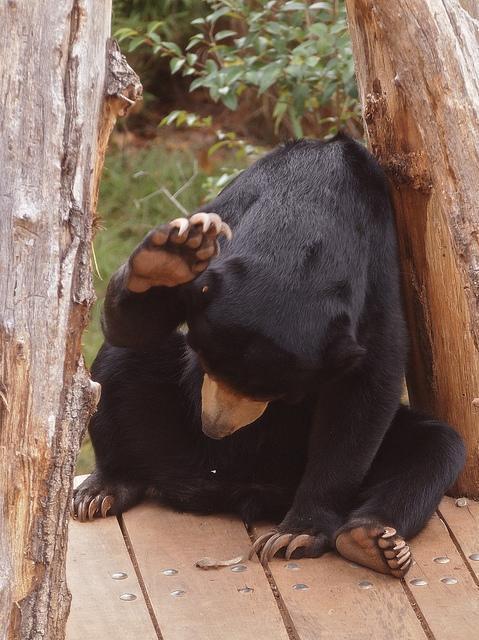How many people are in the plane?
Give a very brief answer. 0. 